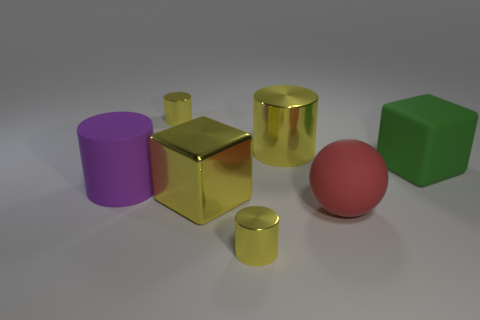There is a yellow cylinder in front of the large green matte thing; how big is it?
Provide a succinct answer. Small. What is the material of the big cylinder that is the same color as the big metal cube?
Offer a very short reply. Metal. There is a rubber cylinder that is the same size as the red matte ball; what is its color?
Make the answer very short. Purple. Are there the same number of big red shiny things and large metal cylinders?
Your answer should be compact. No. Is the size of the green block the same as the red rubber ball?
Provide a short and direct response. Yes. What size is the thing that is both right of the large yellow cylinder and in front of the big rubber cube?
Ensure brevity in your answer.  Large. What number of metal things are either yellow cylinders or cyan blocks?
Offer a very short reply. 3. Are there more yellow metallic cylinders that are behind the purple rubber thing than yellow metallic cubes?
Offer a very short reply. Yes. What is the cylinder that is in front of the matte sphere made of?
Offer a very short reply. Metal. What number of purple things are the same material as the big sphere?
Provide a succinct answer. 1. 